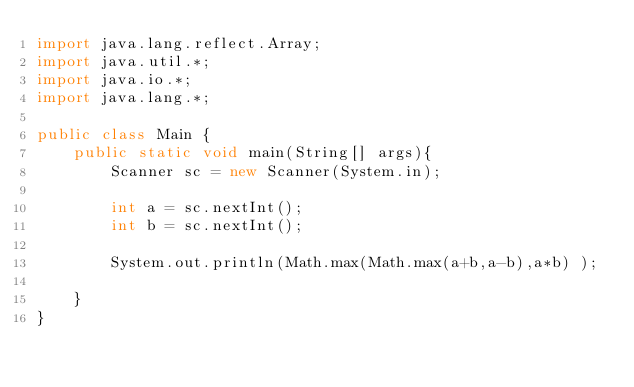<code> <loc_0><loc_0><loc_500><loc_500><_Java_>import java.lang.reflect.Array;
import java.util.*;
import java.io.*;
import java.lang.*;

public class Main {
    public static void main(String[] args){
        Scanner sc = new Scanner(System.in);

        int a = sc.nextInt();
        int b = sc.nextInt();

        System.out.println(Math.max(Math.max(a+b,a-b),a*b) );

    }
}
</code> 